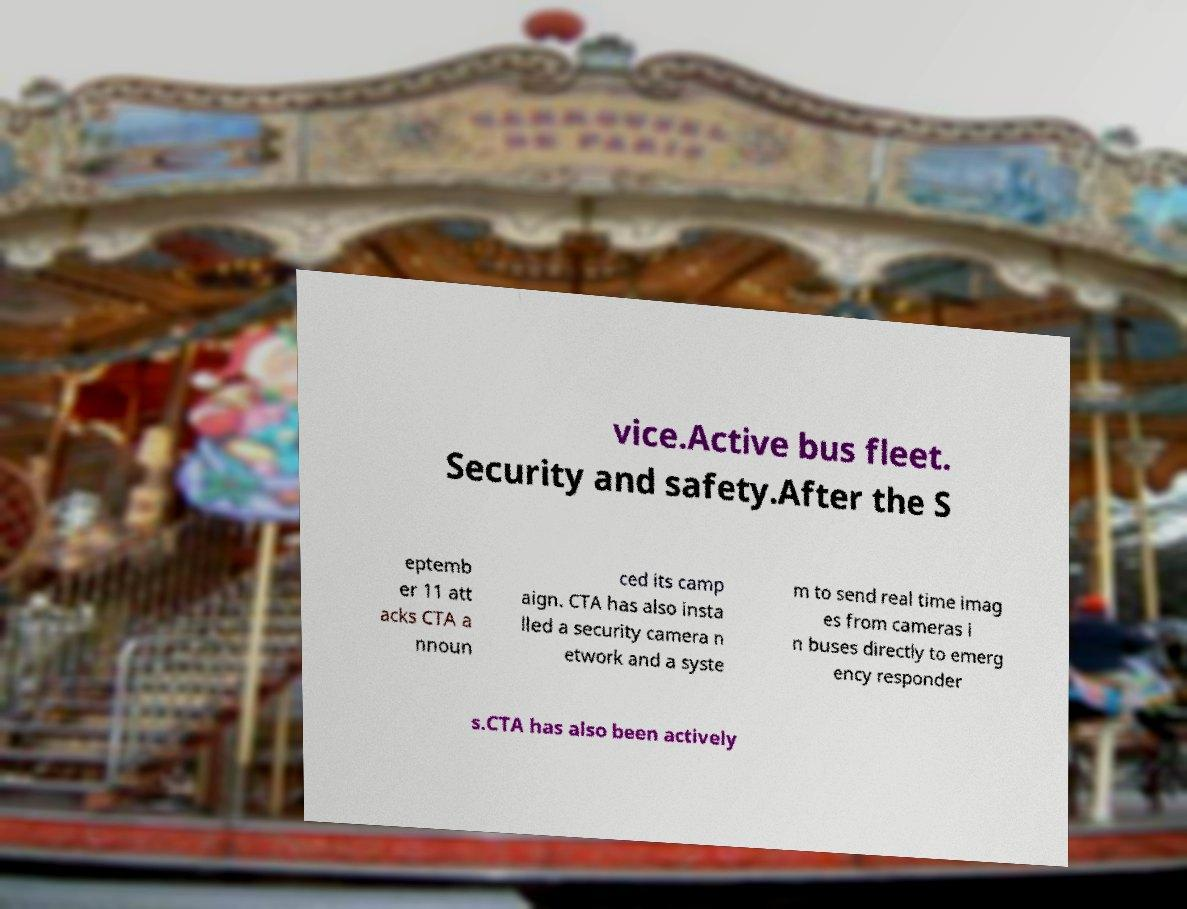Could you extract and type out the text from this image? vice.Active bus fleet. Security and safety.After the S eptemb er 11 att acks CTA a nnoun ced its camp aign. CTA has also insta lled a security camera n etwork and a syste m to send real time imag es from cameras i n buses directly to emerg ency responder s.CTA has also been actively 